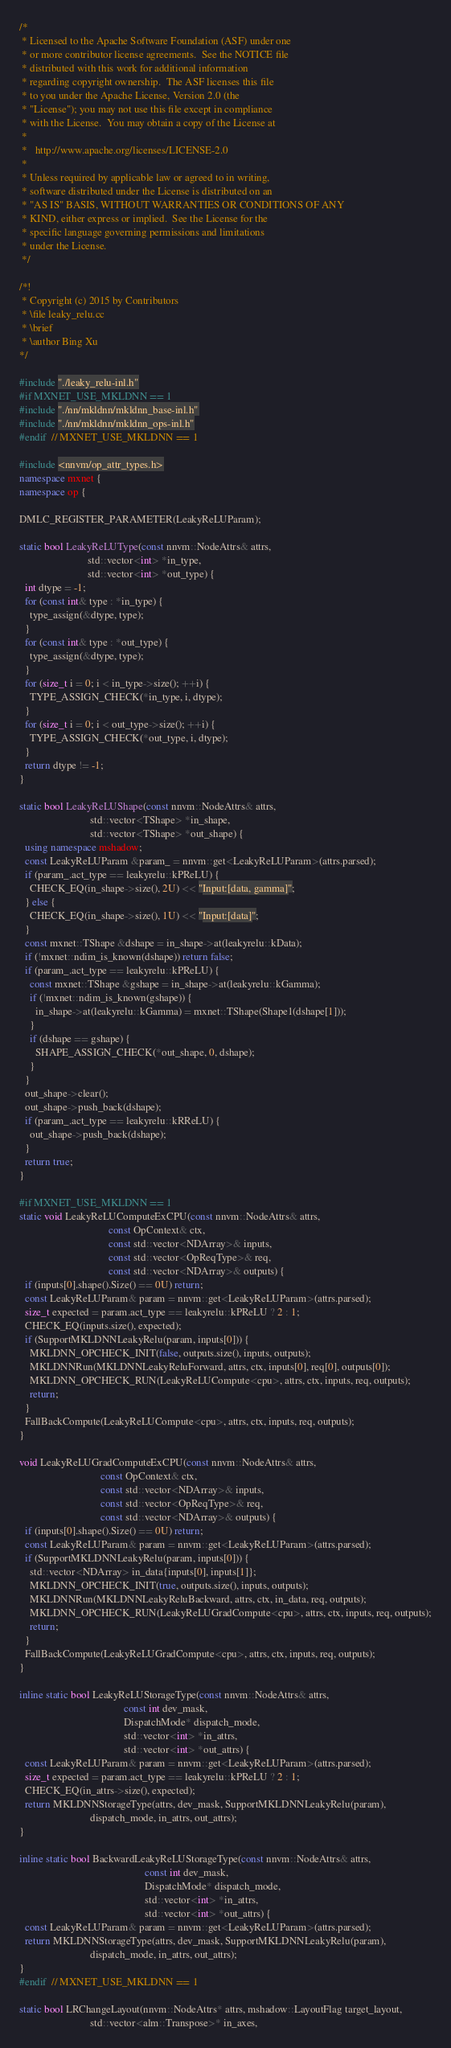Convert code to text. <code><loc_0><loc_0><loc_500><loc_500><_C++_>/*
 * Licensed to the Apache Software Foundation (ASF) under one
 * or more contributor license agreements.  See the NOTICE file
 * distributed with this work for additional information
 * regarding copyright ownership.  The ASF licenses this file
 * to you under the Apache License, Version 2.0 (the
 * "License"); you may not use this file except in compliance
 * with the License.  You may obtain a copy of the License at
 *
 *   http://www.apache.org/licenses/LICENSE-2.0
 *
 * Unless required by applicable law or agreed to in writing,
 * software distributed under the License is distributed on an
 * "AS IS" BASIS, WITHOUT WARRANTIES OR CONDITIONS OF ANY
 * KIND, either express or implied.  See the License for the
 * specific language governing permissions and limitations
 * under the License.
 */

/*!
 * Copyright (c) 2015 by Contributors
 * \file leaky_relu.cc
 * \brief
 * \author Bing Xu
*/

#include "./leaky_relu-inl.h"
#if MXNET_USE_MKLDNN == 1
#include "./nn/mkldnn/mkldnn_base-inl.h"
#include "./nn/mkldnn/mkldnn_ops-inl.h"
#endif  // MXNET_USE_MKLDNN == 1

#include <nnvm/op_attr_types.h>
namespace mxnet {
namespace op {

DMLC_REGISTER_PARAMETER(LeakyReLUParam);

static bool LeakyReLUType(const nnvm::NodeAttrs& attrs,
                          std::vector<int> *in_type,
                          std::vector<int> *out_type) {
  int dtype = -1;
  for (const int& type : *in_type) {
    type_assign(&dtype, type);
  }
  for (const int& type : *out_type) {
    type_assign(&dtype, type);
  }
  for (size_t i = 0; i < in_type->size(); ++i) {
    TYPE_ASSIGN_CHECK(*in_type, i, dtype);
  }
  for (size_t i = 0; i < out_type->size(); ++i) {
    TYPE_ASSIGN_CHECK(*out_type, i, dtype);
  }
  return dtype != -1;
}

static bool LeakyReLUShape(const nnvm::NodeAttrs& attrs,
                           std::vector<TShape> *in_shape,
                           std::vector<TShape> *out_shape) {
  using namespace mshadow;
  const LeakyReLUParam &param_ = nnvm::get<LeakyReLUParam>(attrs.parsed);
  if (param_.act_type == leakyrelu::kPReLU) {
    CHECK_EQ(in_shape->size(), 2U) << "Input:[data, gamma]";
  } else {
    CHECK_EQ(in_shape->size(), 1U) << "Input:[data]";
  }
  const mxnet::TShape &dshape = in_shape->at(leakyrelu::kData);
  if (!mxnet::ndim_is_known(dshape)) return false;
  if (param_.act_type == leakyrelu::kPReLU) {
    const mxnet::TShape &gshape = in_shape->at(leakyrelu::kGamma);
    if (!mxnet::ndim_is_known(gshape)) {
      in_shape->at(leakyrelu::kGamma) = mxnet::TShape(Shape1(dshape[1]));
    }
    if (dshape == gshape) {
      SHAPE_ASSIGN_CHECK(*out_shape, 0, dshape);
    }
  }
  out_shape->clear();
  out_shape->push_back(dshape);
  if (param_.act_type == leakyrelu::kRReLU) {
    out_shape->push_back(dshape);
  }
  return true;
}

#if MXNET_USE_MKLDNN == 1
static void LeakyReLUComputeExCPU(const nnvm::NodeAttrs& attrs,
                                  const OpContext& ctx,
                                  const std::vector<NDArray>& inputs,
                                  const std::vector<OpReqType>& req,
                                  const std::vector<NDArray>& outputs) {
  if (inputs[0].shape().Size() == 0U) return;
  const LeakyReLUParam& param = nnvm::get<LeakyReLUParam>(attrs.parsed);
  size_t expected = param.act_type == leakyrelu::kPReLU ? 2 : 1;
  CHECK_EQ(inputs.size(), expected);
  if (SupportMKLDNNLeakyRelu(param, inputs[0])) {
    MKLDNN_OPCHECK_INIT(false, outputs.size(), inputs, outputs);
    MKLDNNRun(MKLDNNLeakyReluForward, attrs, ctx, inputs[0], req[0], outputs[0]);
    MKLDNN_OPCHECK_RUN(LeakyReLUCompute<cpu>, attrs, ctx, inputs, req, outputs);
    return;
  }
  FallBackCompute(LeakyReLUCompute<cpu>, attrs, ctx, inputs, req, outputs);
}

void LeakyReLUGradComputeExCPU(const nnvm::NodeAttrs& attrs,
                               const OpContext& ctx,
                               const std::vector<NDArray>& inputs,
                               const std::vector<OpReqType>& req,
                               const std::vector<NDArray>& outputs) {
  if (inputs[0].shape().Size() == 0U) return;
  const LeakyReLUParam& param = nnvm::get<LeakyReLUParam>(attrs.parsed);
  if (SupportMKLDNNLeakyRelu(param, inputs[0])) {
    std::vector<NDArray> in_data{inputs[0], inputs[1]};
    MKLDNN_OPCHECK_INIT(true, outputs.size(), inputs, outputs);
    MKLDNNRun(MKLDNNLeakyReluBackward, attrs, ctx, in_data, req, outputs);
    MKLDNN_OPCHECK_RUN(LeakyReLUGradCompute<cpu>, attrs, ctx, inputs, req, outputs);
    return;
  }
  FallBackCompute(LeakyReLUGradCompute<cpu>, attrs, ctx, inputs, req, outputs);
}

inline static bool LeakyReLUStorageType(const nnvm::NodeAttrs& attrs,
                                        const int dev_mask,
                                        DispatchMode* dispatch_mode,
                                        std::vector<int> *in_attrs,
                                        std::vector<int> *out_attrs) {
  const LeakyReLUParam& param = nnvm::get<LeakyReLUParam>(attrs.parsed);
  size_t expected = param.act_type == leakyrelu::kPReLU ? 2 : 1;
  CHECK_EQ(in_attrs->size(), expected);
  return MKLDNNStorageType(attrs, dev_mask, SupportMKLDNNLeakyRelu(param),
                           dispatch_mode, in_attrs, out_attrs);
}

inline static bool BackwardLeakyReLUStorageType(const nnvm::NodeAttrs& attrs,
                                                const int dev_mask,
                                                DispatchMode* dispatch_mode,
                                                std::vector<int> *in_attrs,
                                                std::vector<int> *out_attrs) {
  const LeakyReLUParam& param = nnvm::get<LeakyReLUParam>(attrs.parsed);
  return MKLDNNStorageType(attrs, dev_mask, SupportMKLDNNLeakyRelu(param),
                           dispatch_mode, in_attrs, out_attrs);
}
#endif  // MXNET_USE_MKLDNN == 1

static bool LRChangeLayout(nnvm::NodeAttrs* attrs, mshadow::LayoutFlag target_layout,
                           std::vector<alm::Transpose>* in_axes,</code> 